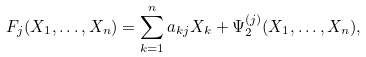Convert formula to latex. <formula><loc_0><loc_0><loc_500><loc_500>F _ { j } ( X _ { 1 } , \dots , X _ { n } ) = \sum _ { k = 1 } ^ { n } a _ { k j } X _ { k } + \Psi _ { 2 } ^ { ( j ) } ( X _ { 1 } , \dots , X _ { n } ) ,</formula> 